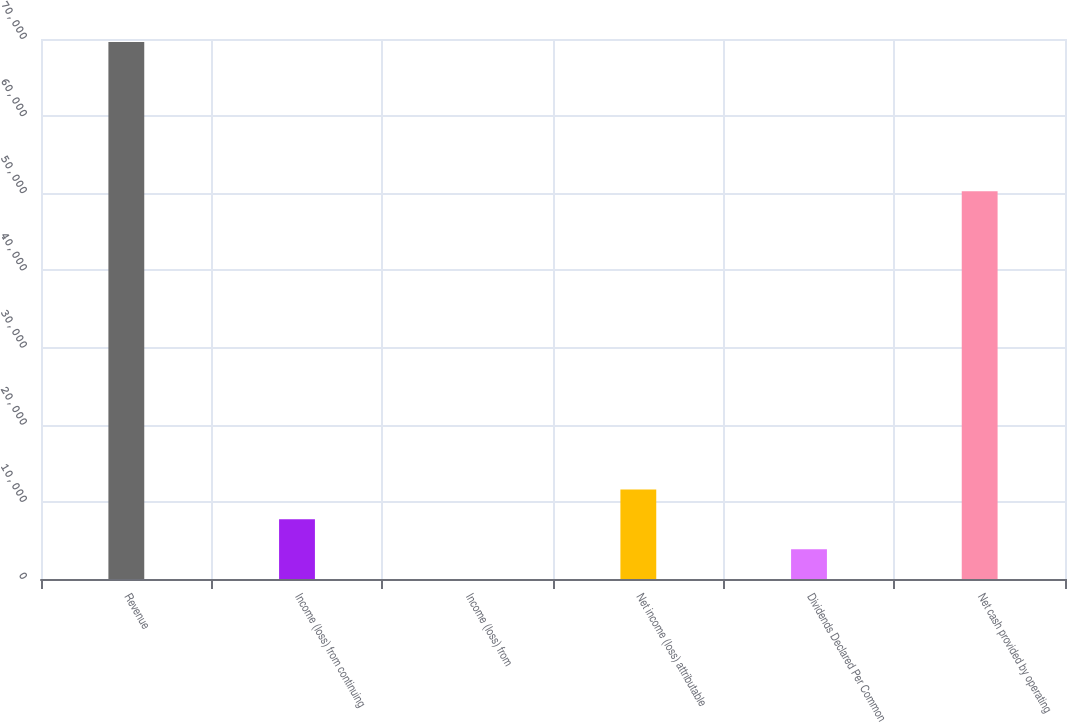Convert chart to OTSL. <chart><loc_0><loc_0><loc_500><loc_500><bar_chart><fcel>Revenue<fcel>Income (loss) from continuing<fcel>Income (loss) from<fcel>Net income (loss) attributable<fcel>Dividends Declared Per Common<fcel>Net cash provided by operating<nl><fcel>69616.8<fcel>7735.31<fcel>0.13<fcel>11602.9<fcel>3867.72<fcel>50278.8<nl></chart> 